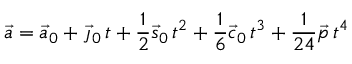Convert formula to latex. <formula><loc_0><loc_0><loc_500><loc_500>{ \vec { a } } = { \vec { a } } _ { 0 } + { \vec { \jmath } } _ { 0 } \, t + { \frac { 1 } { 2 } } { \vec { s } } _ { 0 } \, t ^ { 2 } + { \frac { 1 } { 6 } } { \vec { c } } _ { 0 } \, t ^ { 3 } + { \frac { 1 } { 2 4 } } { \vec { p } } \, t ^ { 4 }</formula> 